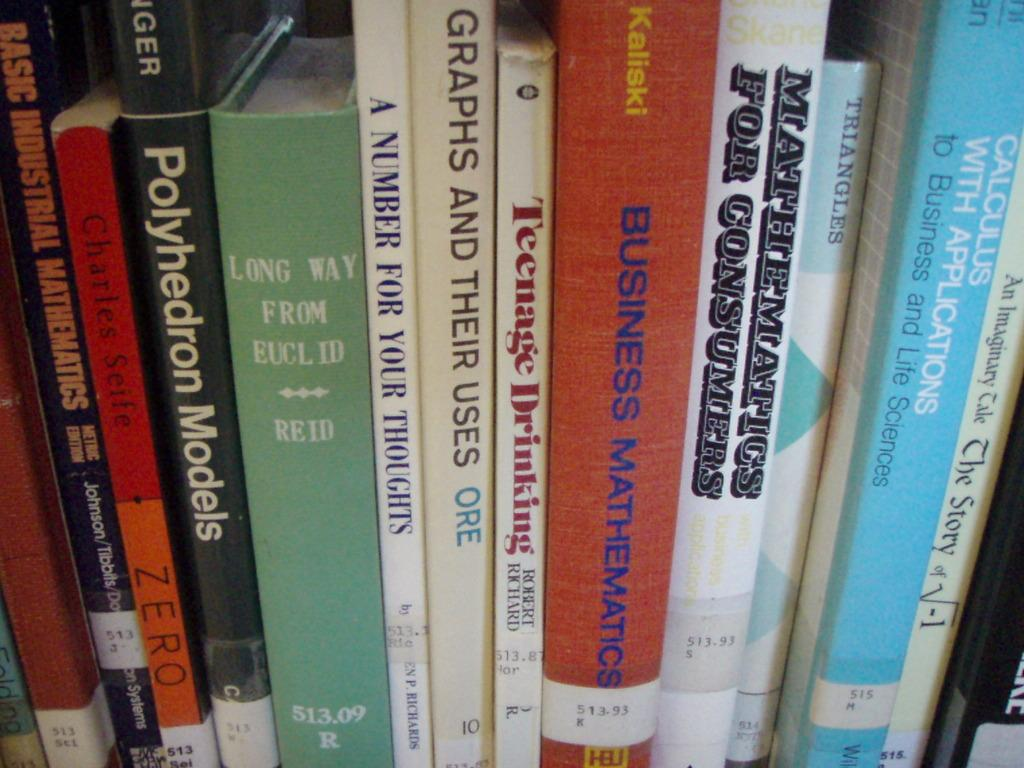Provide a one-sentence caption for the provided image. A row of books covers topics like mathematics and business. 